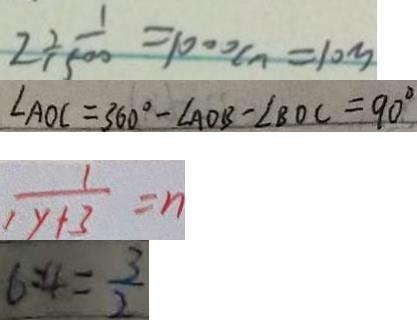<formula> <loc_0><loc_0><loc_500><loc_500>2 \div \frac { 1 } { 1 5 0 0 } = 1 0 0 0 c n = 1 0 m 
 \angle A O C = 3 6 0 ^ { \circ } - \angle A O B - \angle B O C = 9 0 ^ { \circ } 
 \frac { 1 } { 1 y + 3 } = n 
 6 : 4 = \frac { 3 } { 2 }</formula> 